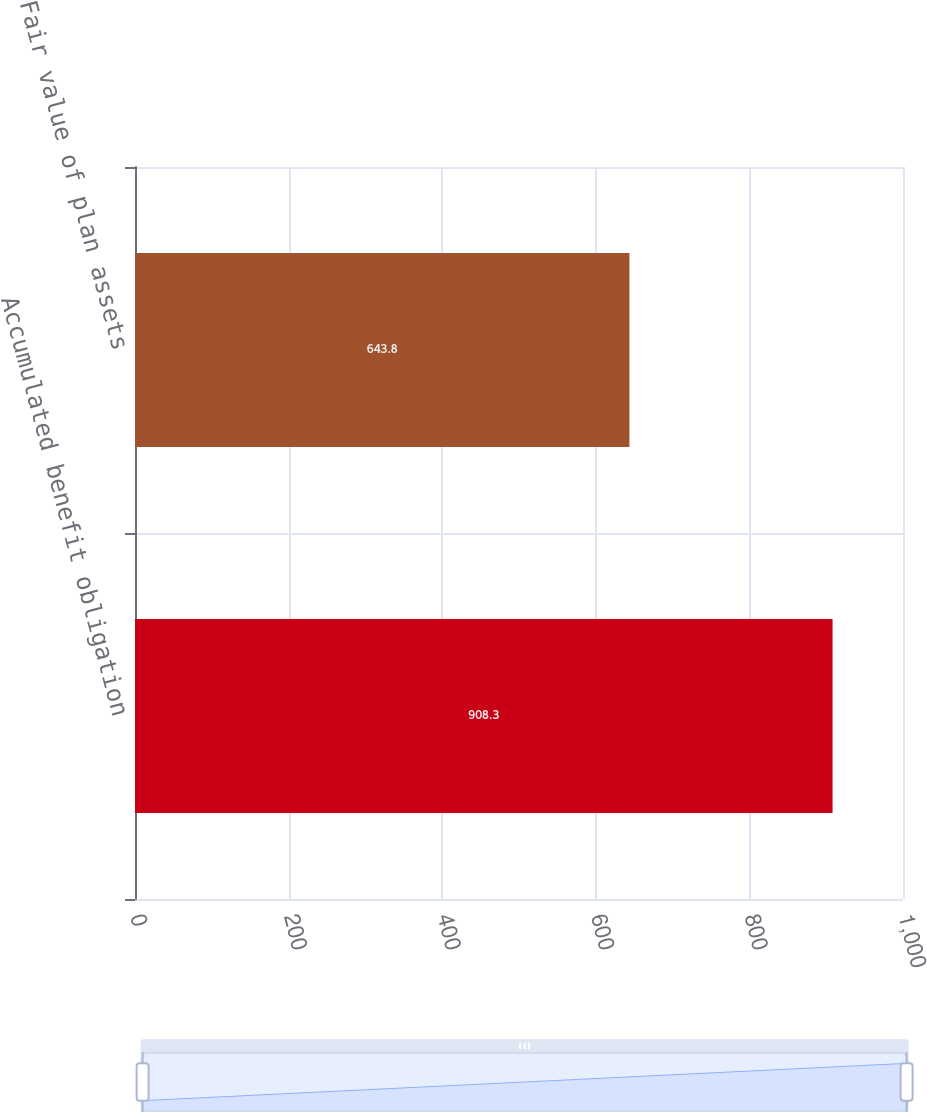Convert chart to OTSL. <chart><loc_0><loc_0><loc_500><loc_500><bar_chart><fcel>Accumulated benefit obligation<fcel>Fair value of plan assets<nl><fcel>908.3<fcel>643.8<nl></chart> 